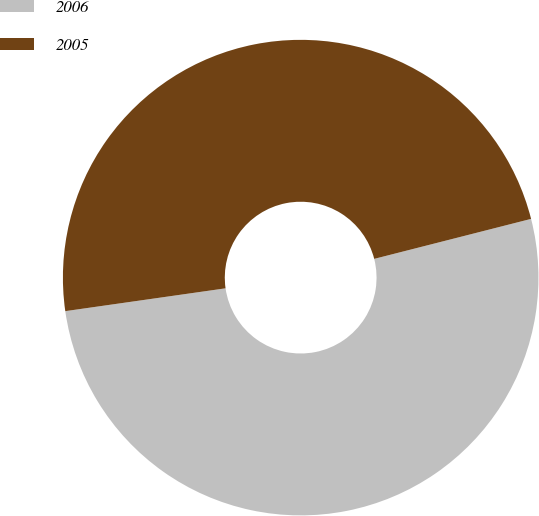Convert chart to OTSL. <chart><loc_0><loc_0><loc_500><loc_500><pie_chart><fcel>2006<fcel>2005<nl><fcel>51.72%<fcel>48.28%<nl></chart> 